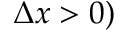Convert formula to latex. <formula><loc_0><loc_0><loc_500><loc_500>\Delta x > 0 )</formula> 